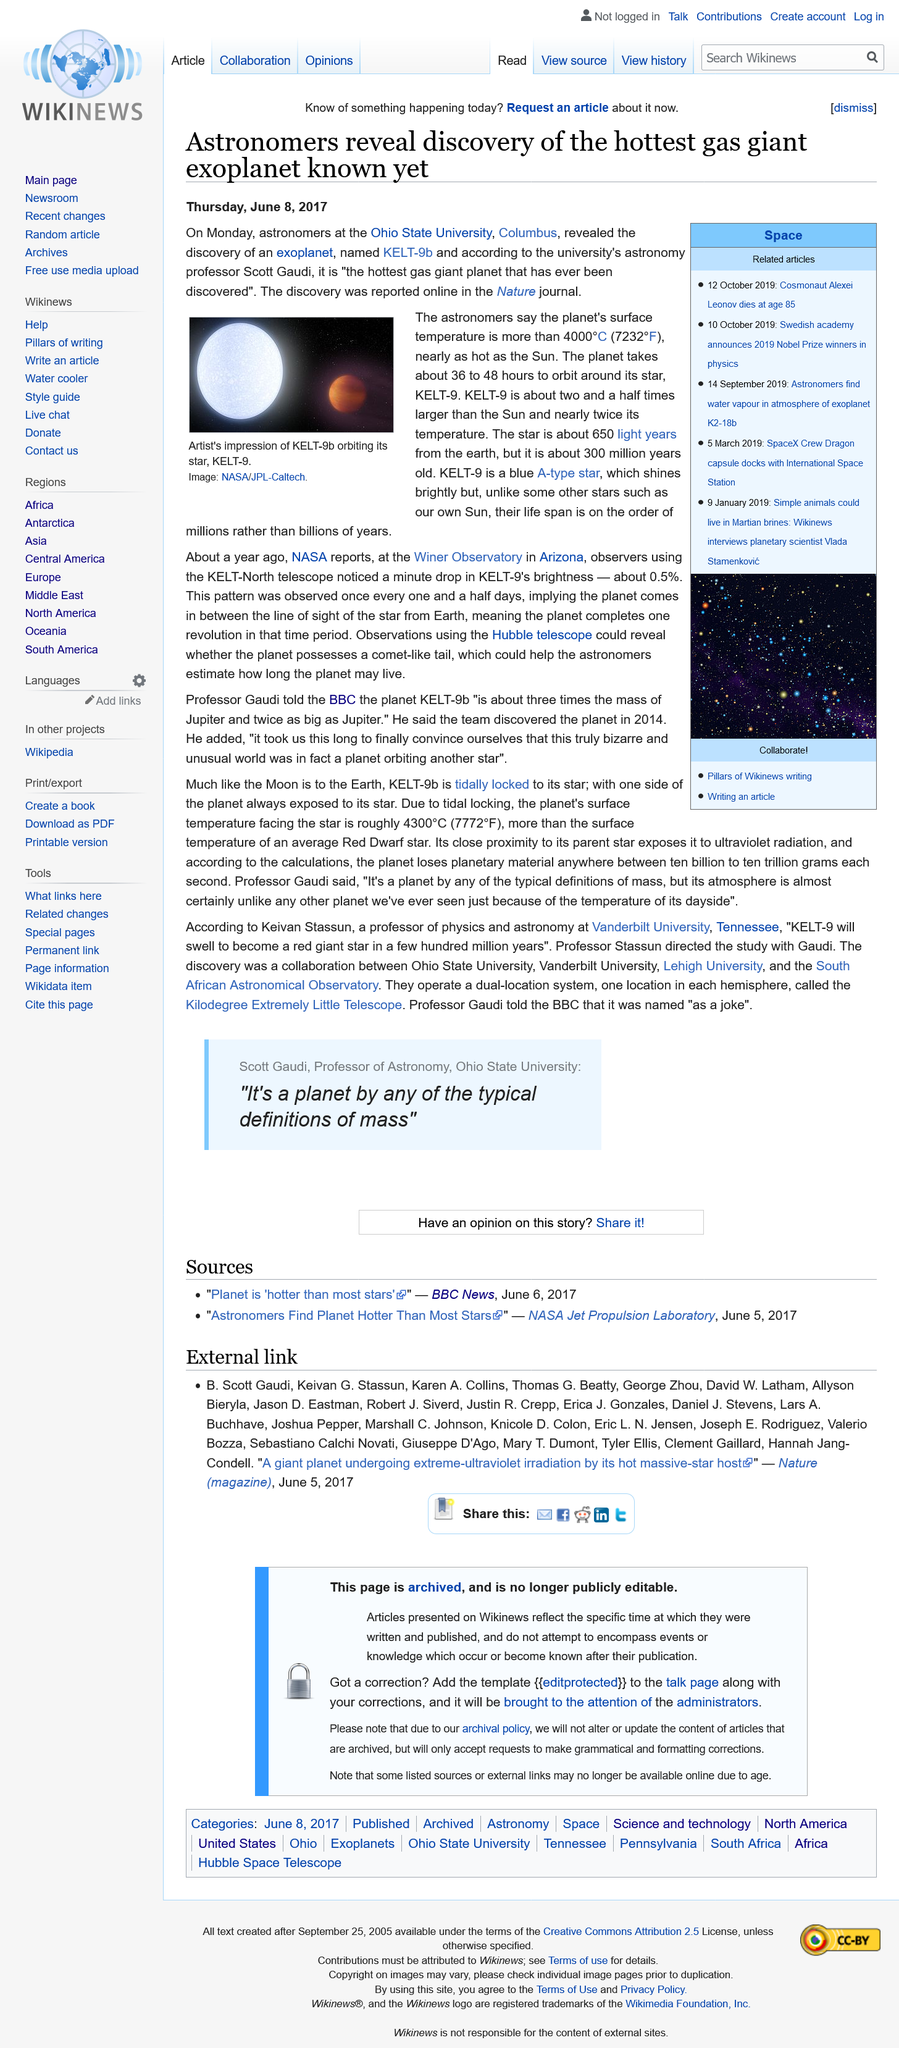Give some essential details in this illustration. KELT-9, a planet located in a distant star, completes its orbit around the star in a period of 36 to 48 hours, making it one of the fastest-orbiting planets known to date. The exoplanet known as KELT-9b was discovered. KELT-9 is approximately two and a half times larger than the Sun, making it a powerful and imposing celestial body. 